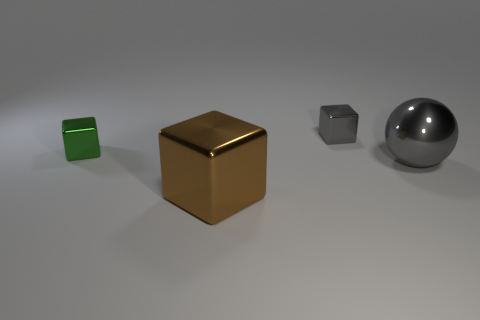The tiny metallic thing that is the same color as the large sphere is what shape?
Make the answer very short. Cube. What number of big yellow balls are the same material as the green block?
Provide a short and direct response. 0. What number of blocks are the same color as the ball?
Provide a succinct answer. 1. How many objects are metallic things on the right side of the brown cube or metal things behind the small green metal object?
Offer a very short reply. 2. Are there fewer spheres in front of the brown metal object than small blue rubber balls?
Offer a terse response. No. Is there a blue rubber thing of the same size as the brown metallic object?
Keep it short and to the point. No. What is the color of the large cube?
Make the answer very short. Brown. Do the gray sphere and the green shiny cube have the same size?
Your answer should be very brief. No. What number of objects are big red cubes or gray shiny things?
Your answer should be very brief. 2. Is the number of gray shiny blocks that are in front of the big brown shiny thing the same as the number of large gray rubber balls?
Provide a succinct answer. Yes. 